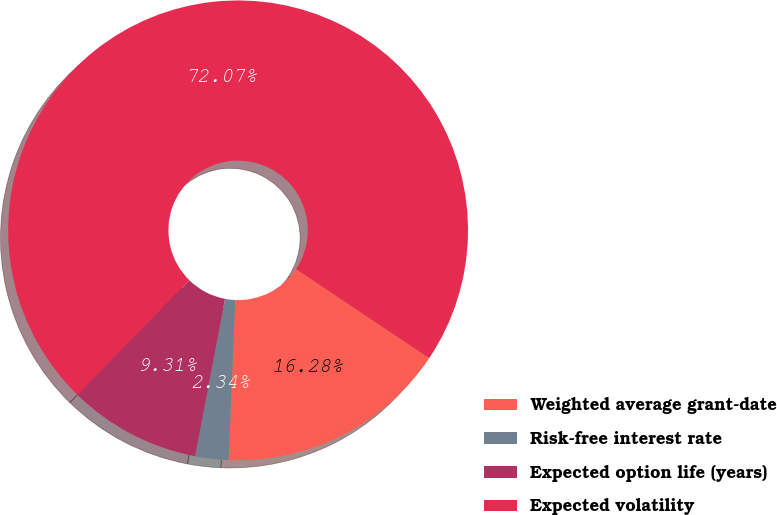<chart> <loc_0><loc_0><loc_500><loc_500><pie_chart><fcel>Weighted average grant-date<fcel>Risk-free interest rate<fcel>Expected option life (years)<fcel>Expected volatility<nl><fcel>16.28%<fcel>2.34%<fcel>9.31%<fcel>72.07%<nl></chart> 